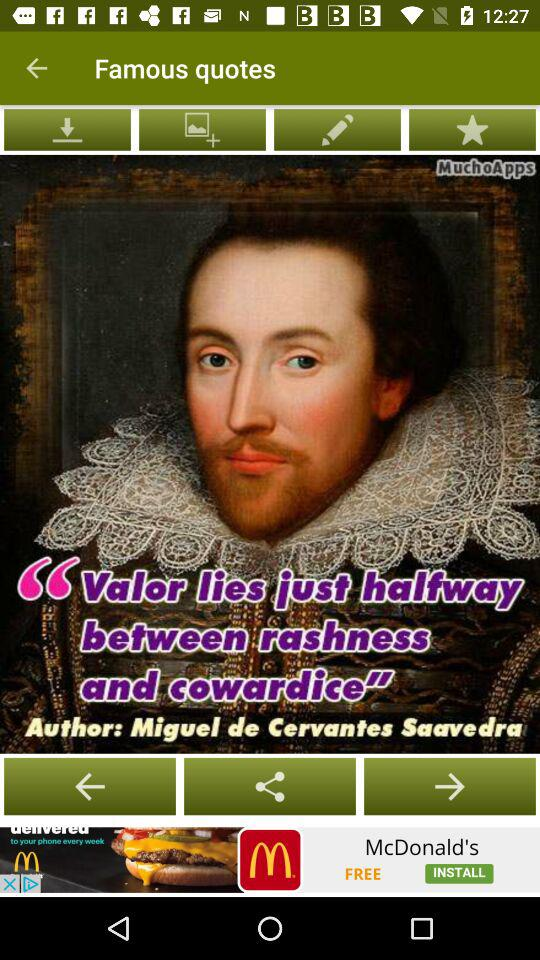What is the quote? The quote is "Valor lies just halfway between rashness and cowardice". 